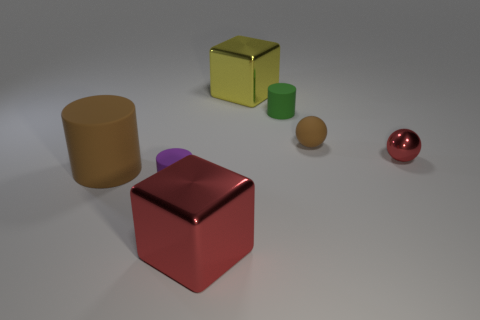Subtract all small purple cylinders. How many cylinders are left? 2 Subtract all brown cylinders. How many cylinders are left? 2 Add 2 big red metallic blocks. How many objects exist? 9 Subtract all gray cylinders. Subtract all purple blocks. How many cylinders are left? 3 Subtract all blocks. How many objects are left? 5 Subtract 0 blue cylinders. How many objects are left? 7 Subtract all small red metallic balls. Subtract all red things. How many objects are left? 4 Add 3 tiny brown things. How many tiny brown things are left? 4 Add 5 big red shiny things. How many big red shiny things exist? 6 